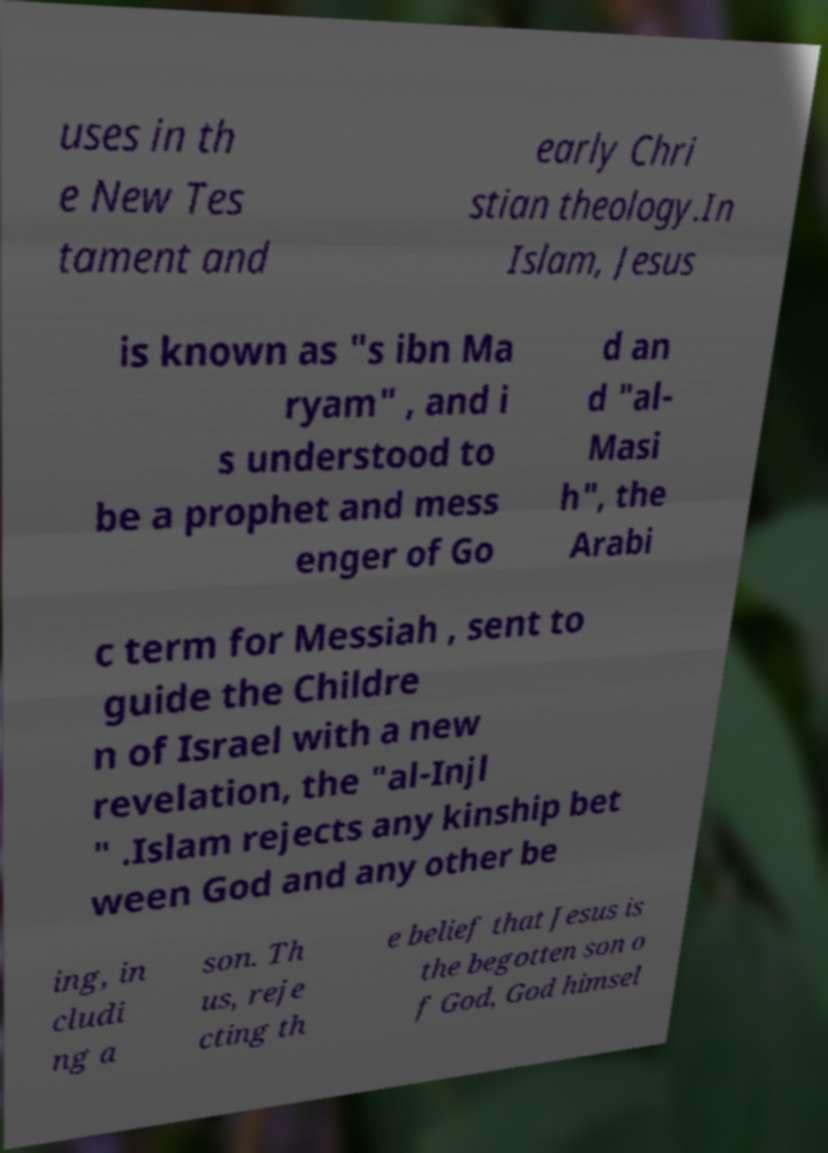Could you assist in decoding the text presented in this image and type it out clearly? uses in th e New Tes tament and early Chri stian theology.In Islam, Jesus is known as "s ibn Ma ryam" , and i s understood to be a prophet and mess enger of Go d an d "al- Masi h", the Arabi c term for Messiah , sent to guide the Childre n of Israel with a new revelation, the "al-Injl " .Islam rejects any kinship bet ween God and any other be ing, in cludi ng a son. Th us, reje cting th e belief that Jesus is the begotten son o f God, God himsel 